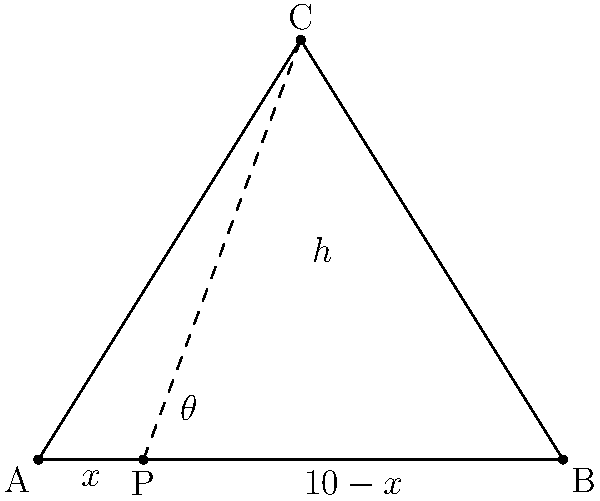As a luxury property developer, you're designing a rooftop infinity pool for a high-end resort. The pool's edge is triangular, with one side parallel to the building's edge. The building's width is 10 meters, and the pool's apex is 8 meters from the building's edge. To maximize the view angle for guests, you need to determine the optimal position for the viewing platform (point P) along the building's edge. If the viewing platform is placed x meters from one end of the building, what value of x will maximize the viewing angle θ? Let's approach this step-by-step:

1) In the triangle ABC, we know:
   AB = 10 meters (building width)
   AC = BC = $\sqrt{5^2 + 8^2} = \sqrt{89}$ meters (using Pythagorean theorem)

2) The angle θ at point P is formed by PC and PB. We can express tan(θ) as:

   $$\tan(\theta) = \frac{h}{10-x} - \frac{h}{x}$$

   where h is the height of the triangle (8 meters).

3) To maximize θ, we need to maximize tan(θ). The maximum of a function occurs where its derivative equals zero. So, we differentiate tan(θ) with respect to x and set it to zero:

   $$\frac{d}{dx}\tan(\theta) = \frac{h}{x^2} - \frac{h}{(10-x)^2} = 0$$

4) Solving this equation:

   $$\frac{1}{x^2} = \frac{1}{(10-x)^2}$$
   $$10-x = x$$
   $$10 = 2x$$
   $$x = 5$$

5) To confirm this is a maximum, we can check the second derivative is negative at x=5 (which it is).

Therefore, the viewing angle θ is maximized when the platform is placed exactly in the middle of the building's edge, 5 meters from either end.
Answer: 5 meters 